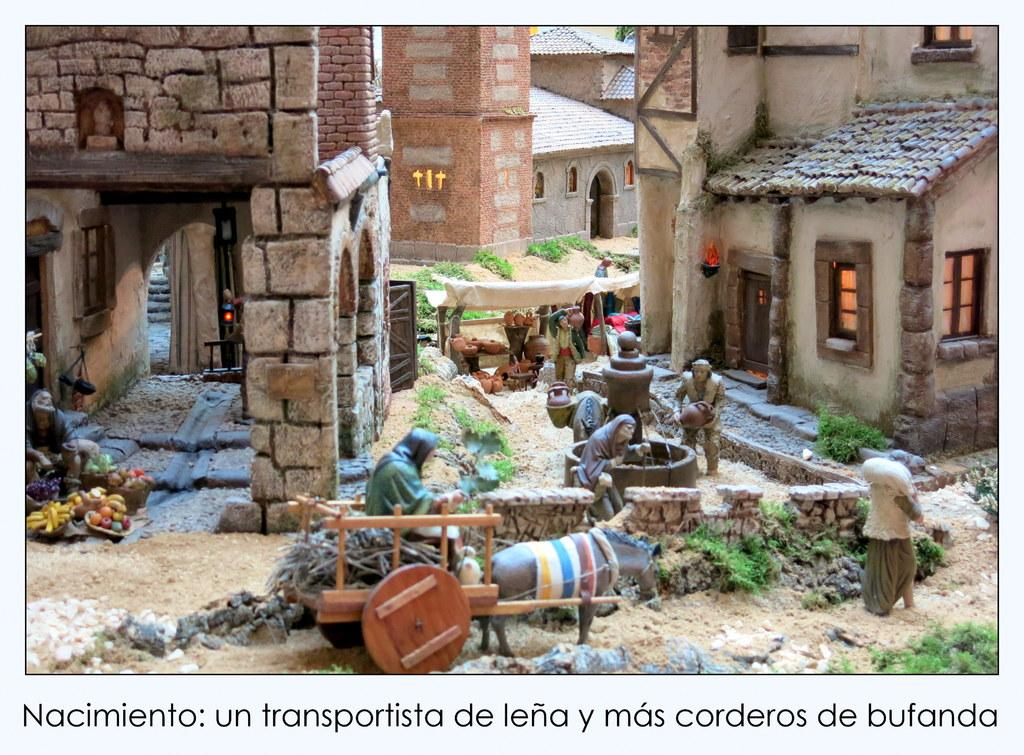What types of subjects are depicted in the image? There are depictions of persons, houses, fruits, and animals in the image. Can you describe the various elements in the image? Yes, the image contains depictions of persons, houses, fruits, and animals. Is there any text present in the image? Yes, there is text at the bottom of the image. What type of sheet is being used by the aunt in the image? There is no aunt or sheet present in the image. What is the price of the depicted fruits in the image? The image does not provide any information about the price of the fruits. 